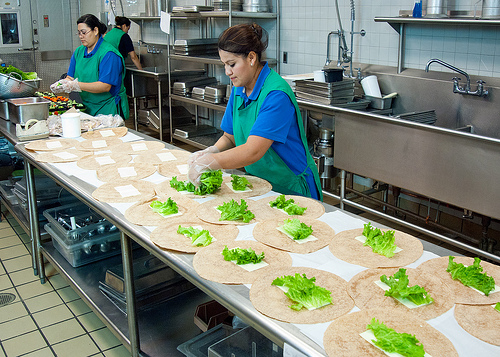Please provide a short description for this region: [0.44, 0.31, 0.69, 0.57]. A green apron worn by a woman preparing food. The apron covers her from just above the waist to her mid-thighs, providing protection while she works. 